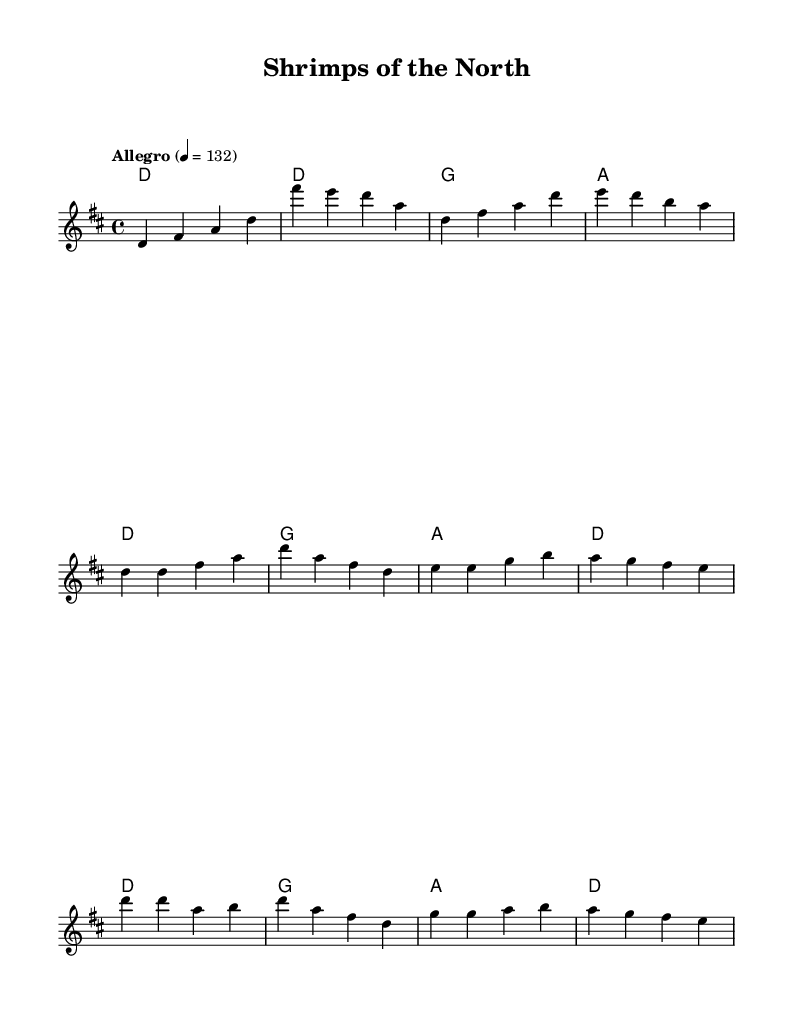What is the key signature of this music? The key signature indicated in the sheet music is D major, which has two sharps (F# and C#). This can be identified by looking at the sharp symbols at the beginning of the staff.
Answer: D major What is the time signature of the piece? The time signature shown in the sheet music is 4/4. This is located at the beginning of the score and indicates that there are four beats in each measure, and the quarter note gets one beat.
Answer: 4/4 What is the tempo marking for the piece? The tempo marking states "Allegro" with a metronome indication of 132 beats per minute. This can be found near the top of the sheet music, which indicates how fast the piece should be played.
Answer: Allegro, 132 How many measures are in the verse? The verse section contains four measures, as indicated by the grouping of notes and the spaces between the verse lyrics. Each line typically represents a measure, and counting them gives the total number.
Answer: 4 What lyrical theme is present in the chorus? The lyrical theme in the chorus revolves around working-class loyalty and football pride, specifically celebrating Morecambe FC. This can be deduced from the words presented in the chorus section of the lyrics above the corresponding musical notes.
Answer: Working-class loyalty Which chords are used during the chorus? The chords used during the chorus are D, G, and A, as seen in the chord symbols written above the melody in the chorus section of the sheet music.
Answer: D, G, A What is the significance of the title "Shrimps of the North"? The title "Shrimps of the North" signifies a connection to Morecambe FC, as it is a nickname for the team, representing local pride and identity. This is highlighted in the context of the lyrics and the thematic content of the music related to working-class roots.
Answer: Connection to Morecambe FC 